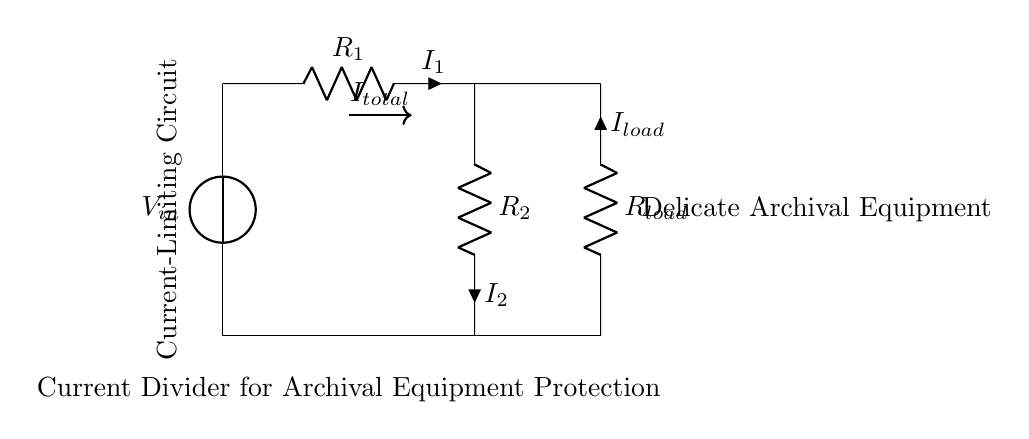What is the input voltage of the circuit? The input voltage is shown as V_in in the circuit diagram. Since it's not assigned a specific value, we can only refer to it as V_in.
Answer: V_in What are the resistance values of R1 and R2? The values of R1 and R2 are not specified in the diagram; they are labeled simply as R1 and R2 without numerical values.
Answer: R1, R2 What is the function of the current-limiting circuit? The function of the current-limiting circuit is to divide current between the load and protect delicate archival equipment from overcurrent, ensuring that it operates safely within specified limits.
Answer: Protects equipment How is the total current I_total determined in the circuit? The total current I_total enters the circuit from the voltage source V_in and is divided between R1 and R2 based on their resistance values. Using Ohm’s law, it can be calculated as I_total = V_in / (R1 + R2).
Answer: Based on resistances What happens to the load current I_load if R2 is increased? If R2 is increased, the current I_load through R_load would decrease because the voltage drop across R2 would be greater, leading to a smaller current division towards the load according to the current divider rule.
Answer: Decreases Which component directly connects to the delicate archival equipment? The component that connects directly to the delicate archival equipment is R_load, as indicated in the circuit diagram, which is labeled accordingly.
Answer: R_load 